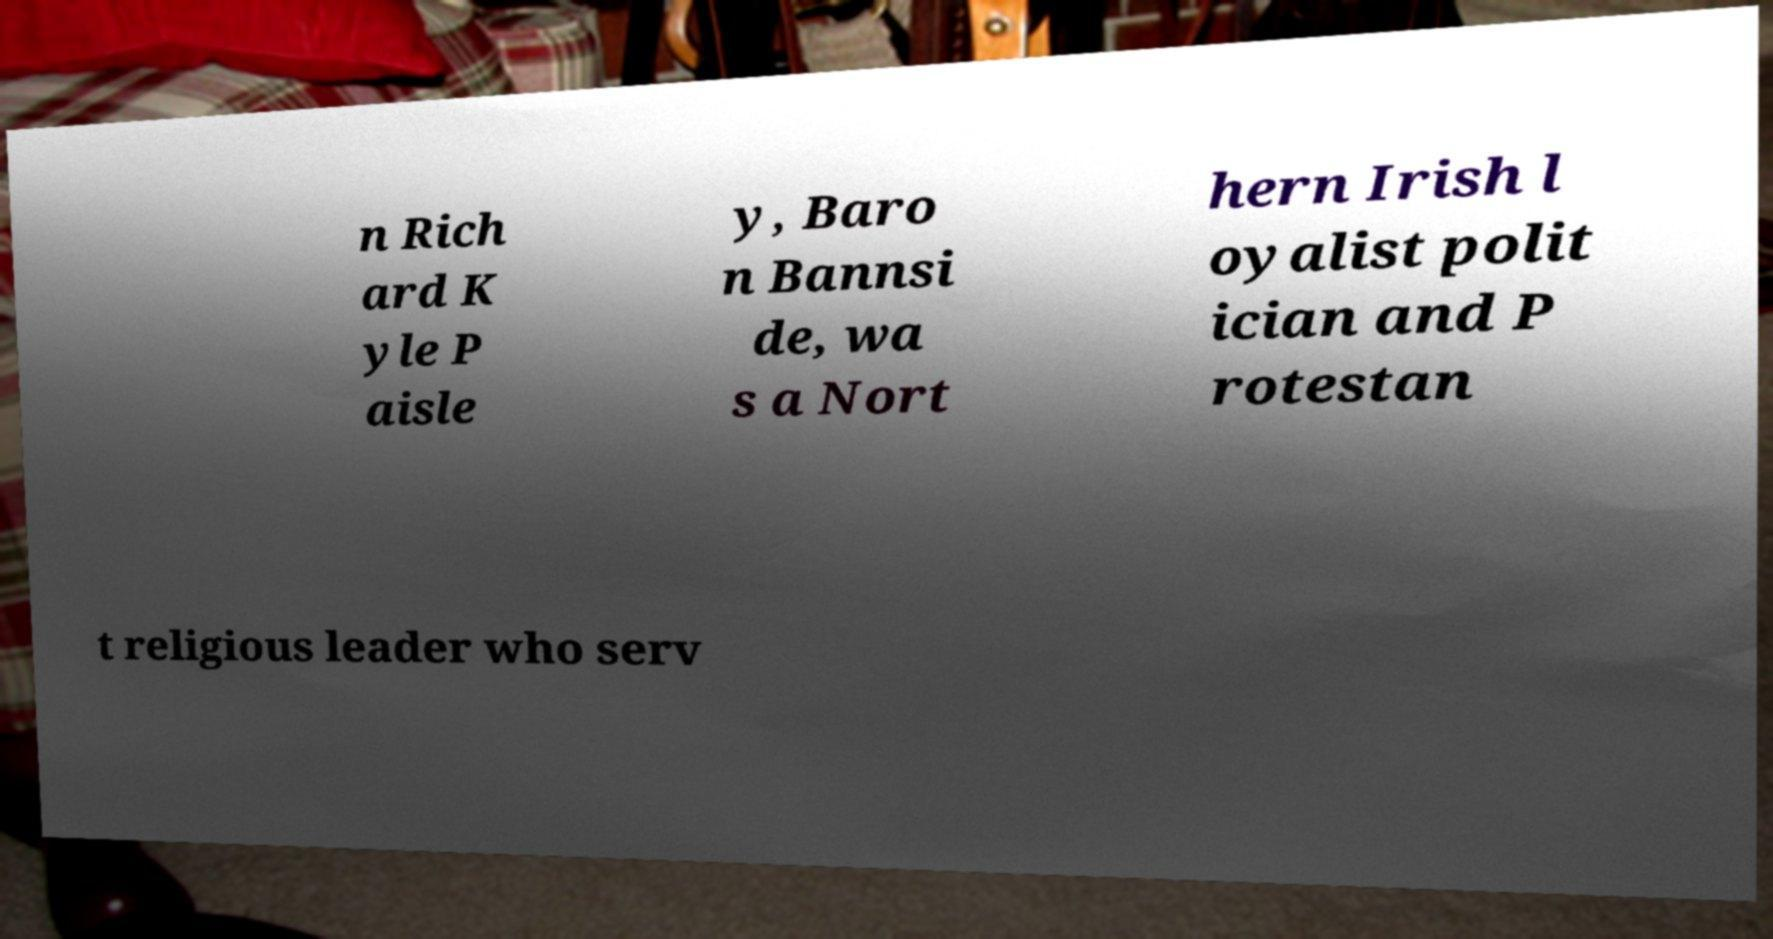Can you accurately transcribe the text from the provided image for me? n Rich ard K yle P aisle y, Baro n Bannsi de, wa s a Nort hern Irish l oyalist polit ician and P rotestan t religious leader who serv 